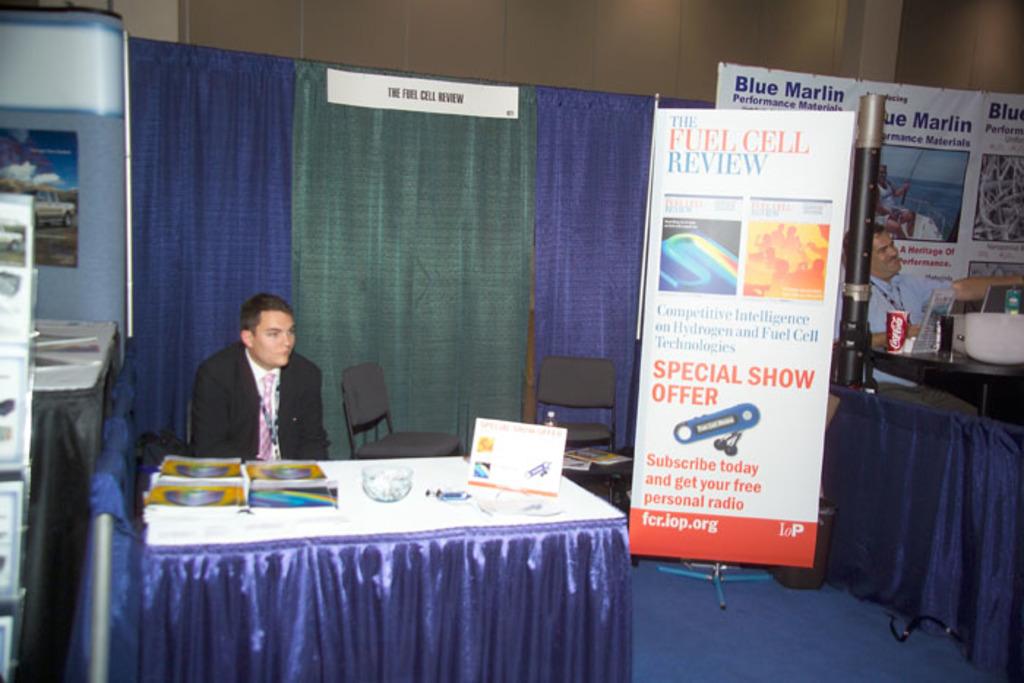What is being reviewed?
Your answer should be very brief. Fuel cell. 